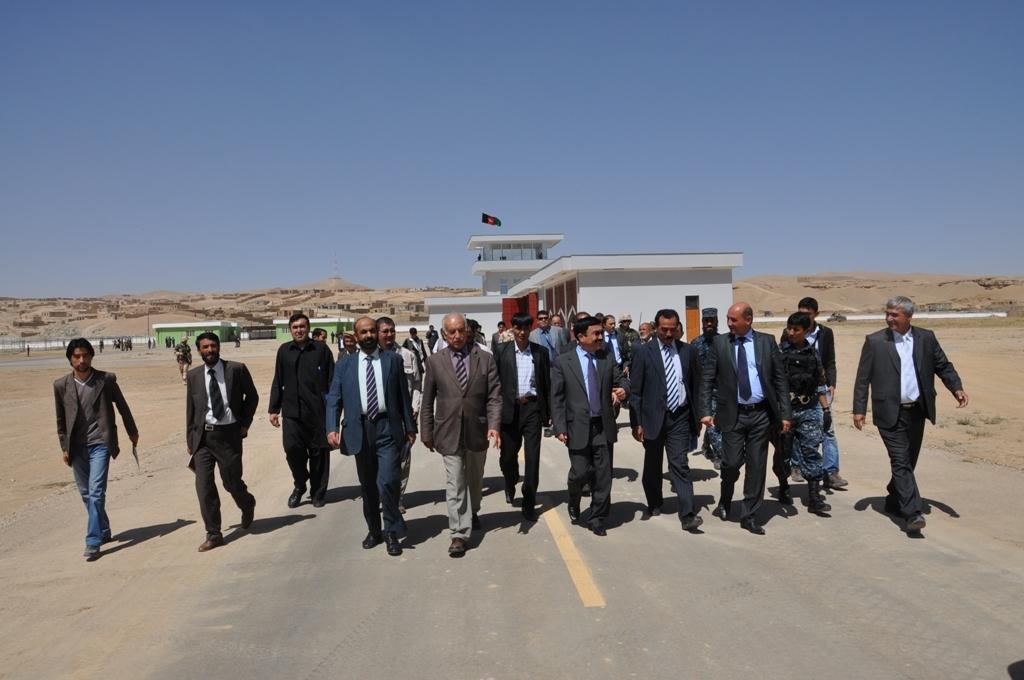Please provide a concise description of this image. In this image we can see people with suits walking on the road. In the background we can see some buildings. Image also consists of poles and flag. At the top there is sky. 